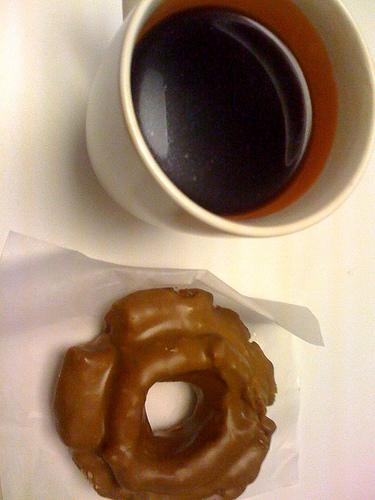Question: how many cups are there?
Choices:
A. Two.
B. One.
C. Three.
D. Four.
Answer with the letter. Answer: B Question: what color is the donut?
Choices:
A. White.
B. Pink.
C. Purple.
D. Brown.
Answer with the letter. Answer: D Question: where was the photo taken?
Choices:
A. On a counter.
B. On a night stand.
C. On a shelf.
D. On a table.
Answer with the letter. Answer: D 